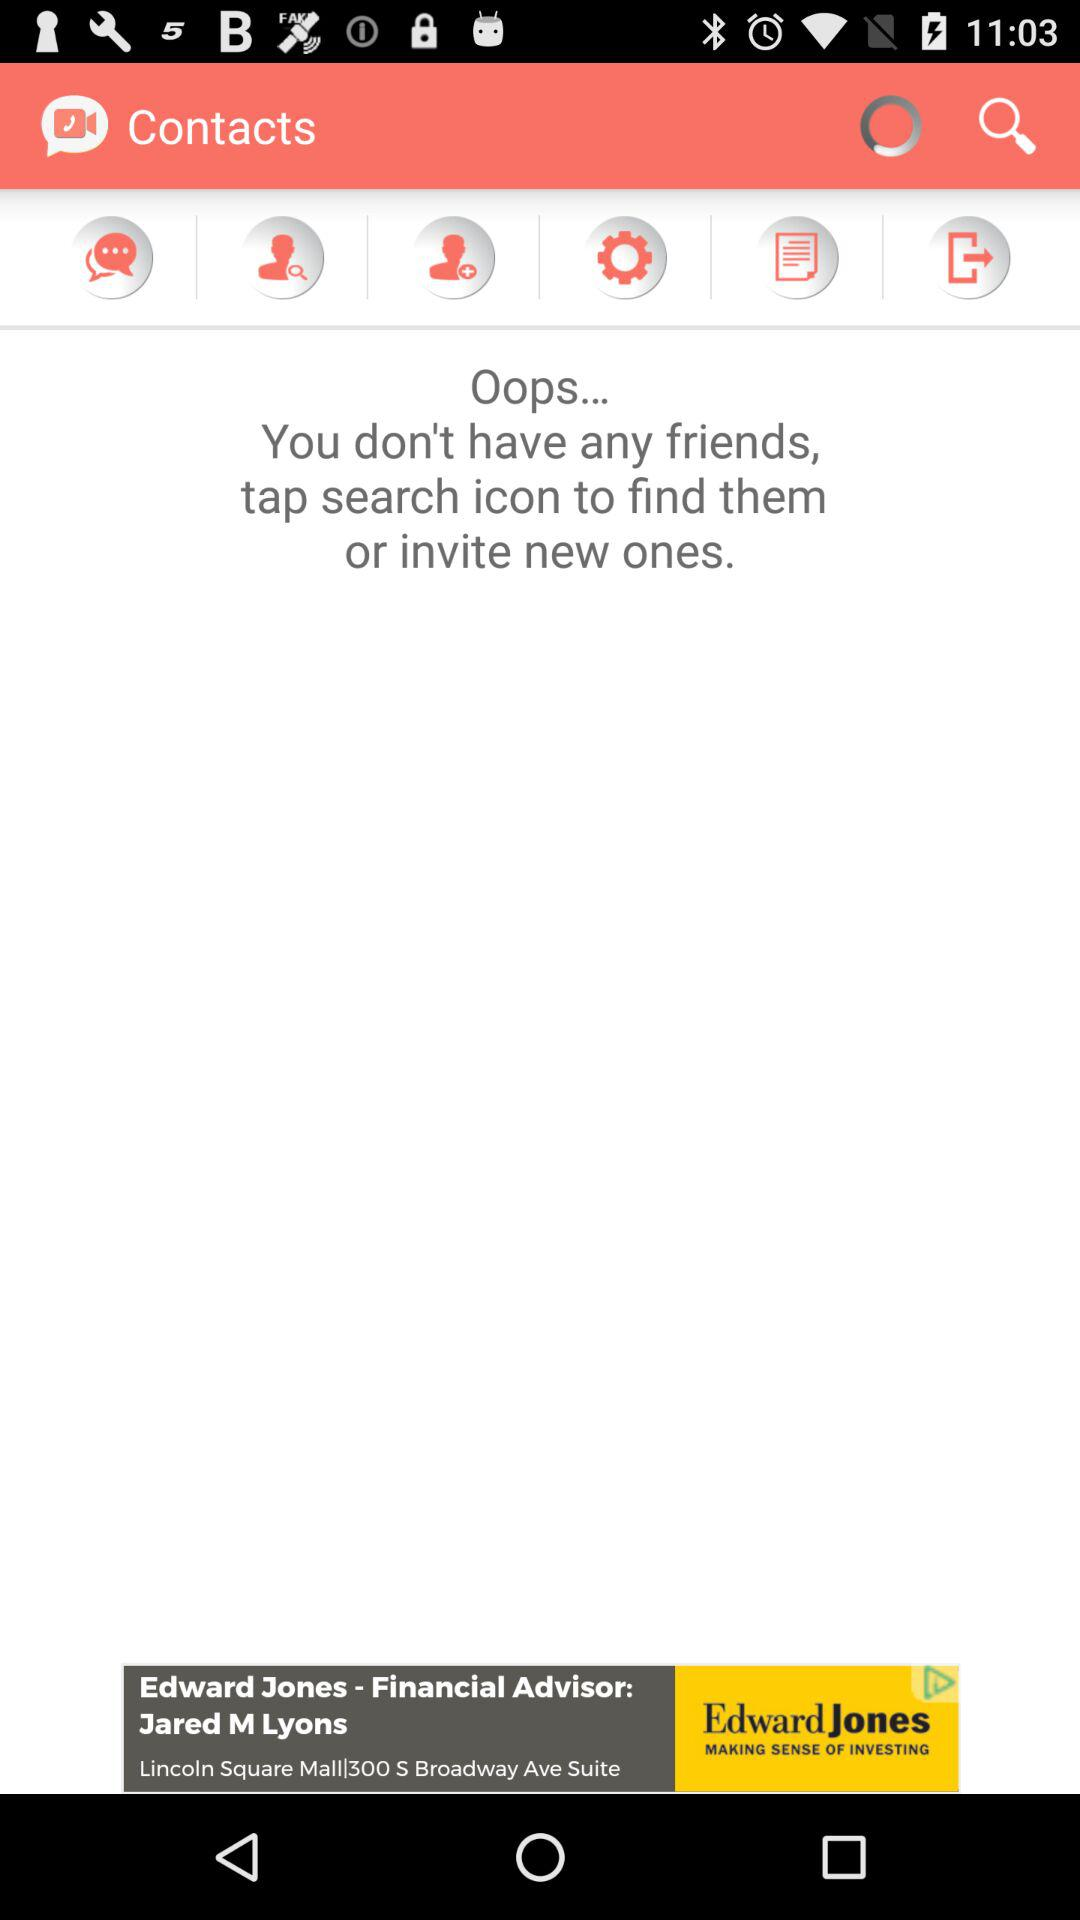How many more friends do I need to have to not see the 'Oops... You don't have any friends' message?
Answer the question using a single word or phrase. 1 